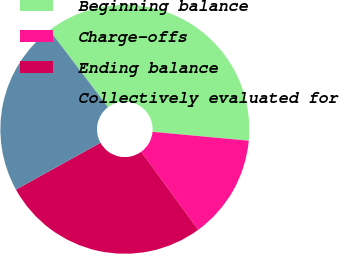Convert chart. <chart><loc_0><loc_0><loc_500><loc_500><pie_chart><fcel>Beginning balance<fcel>Charge-offs<fcel>Ending balance<fcel>Collectively evaluated for<nl><fcel>36.81%<fcel>13.5%<fcel>26.99%<fcel>22.7%<nl></chart> 